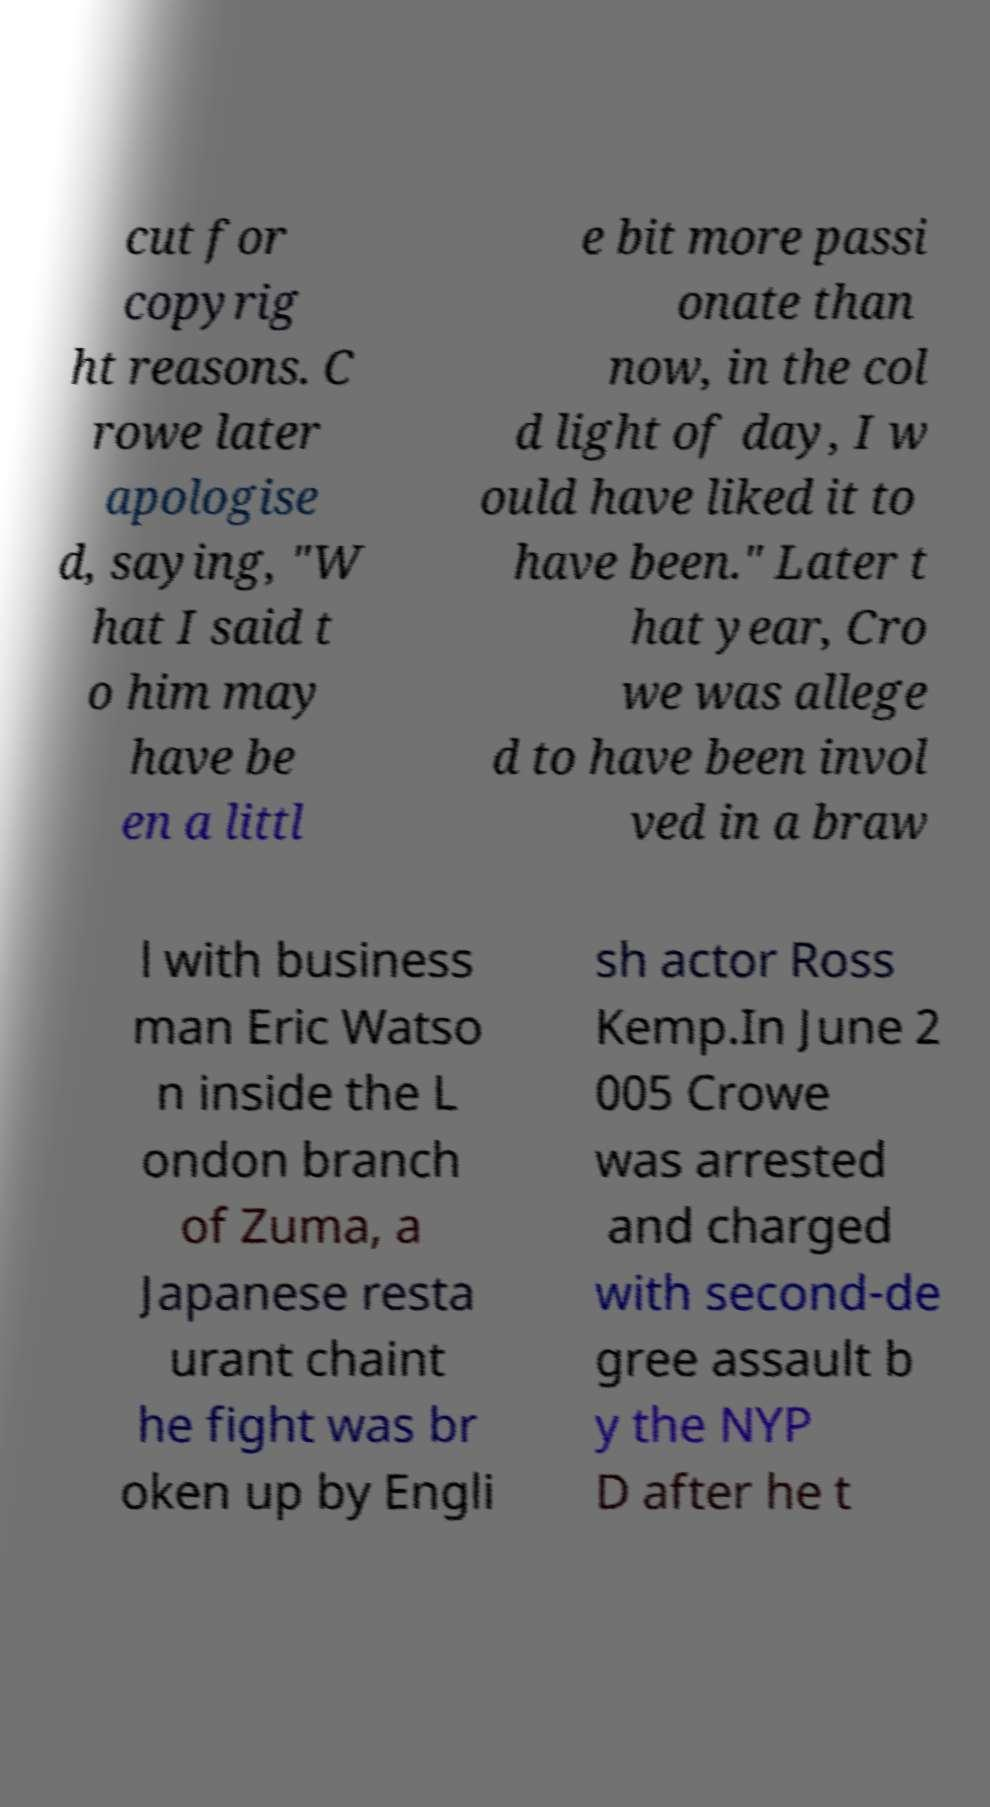What messages or text are displayed in this image? I need them in a readable, typed format. cut for copyrig ht reasons. C rowe later apologise d, saying, "W hat I said t o him may have be en a littl e bit more passi onate than now, in the col d light of day, I w ould have liked it to have been." Later t hat year, Cro we was allege d to have been invol ved in a braw l with business man Eric Watso n inside the L ondon branch of Zuma, a Japanese resta urant chaint he fight was br oken up by Engli sh actor Ross Kemp.In June 2 005 Crowe was arrested and charged with second-de gree assault b y the NYP D after he t 